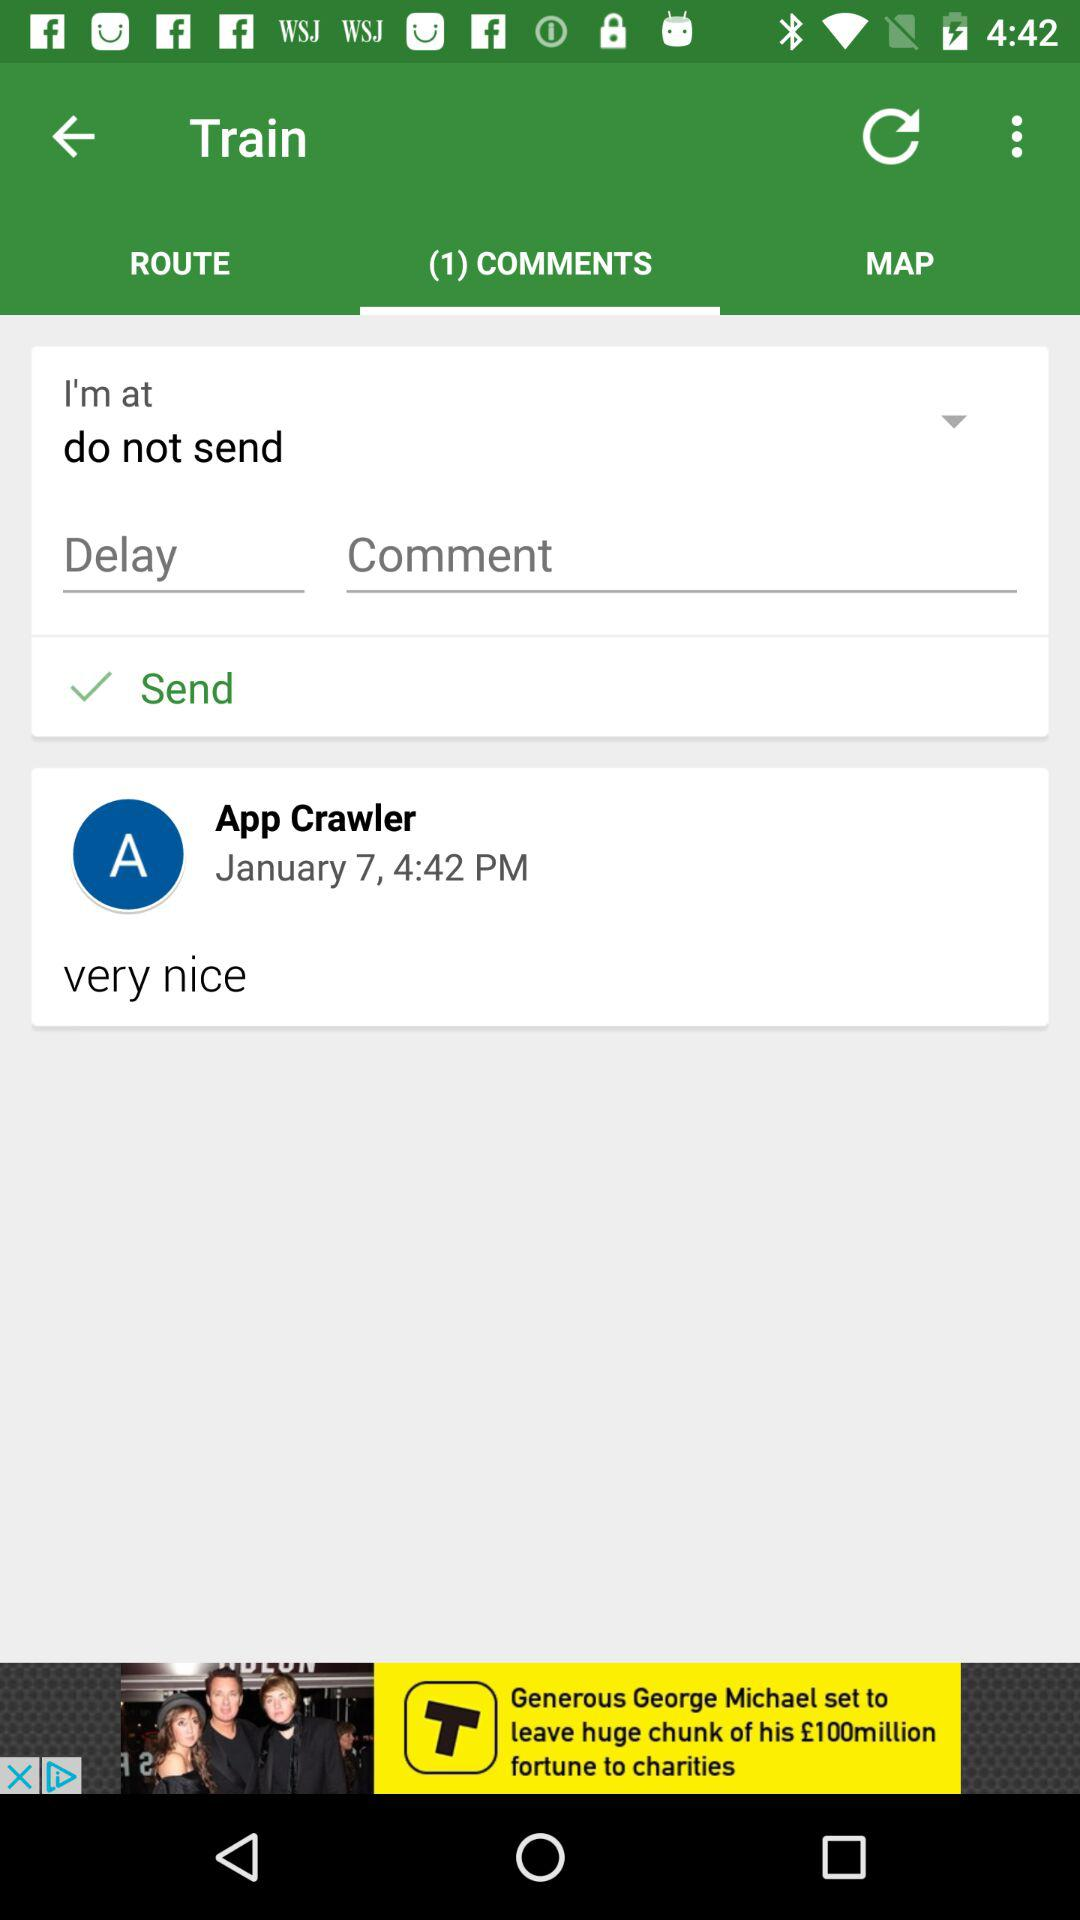What date and time is shown? The shown date is January 7 and the time is 4:42 PM. 